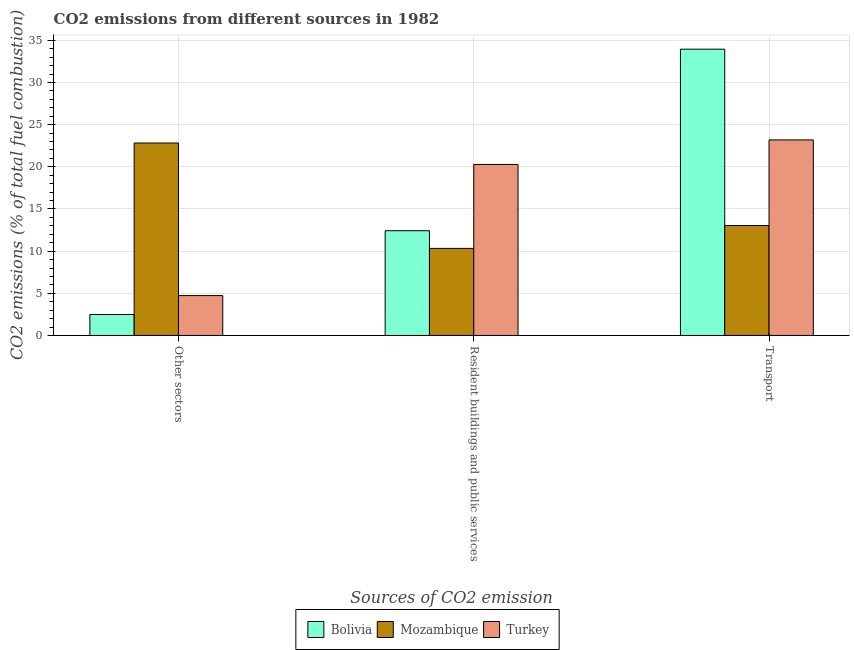How many bars are there on the 3rd tick from the right?
Keep it short and to the point. 3. What is the label of the 2nd group of bars from the left?
Provide a succinct answer. Resident buildings and public services. What is the percentage of co2 emissions from resident buildings and public services in Turkey?
Make the answer very short. 20.28. Across all countries, what is the maximum percentage of co2 emissions from resident buildings and public services?
Ensure brevity in your answer.  20.28. Across all countries, what is the minimum percentage of co2 emissions from transport?
Make the answer very short. 13.04. In which country was the percentage of co2 emissions from other sectors maximum?
Your answer should be very brief. Mozambique. In which country was the percentage of co2 emissions from resident buildings and public services minimum?
Your response must be concise. Mozambique. What is the total percentage of co2 emissions from other sectors in the graph?
Ensure brevity in your answer.  30.04. What is the difference between the percentage of co2 emissions from other sectors in Mozambique and that in Bolivia?
Offer a terse response. 20.34. What is the difference between the percentage of co2 emissions from other sectors in Bolivia and the percentage of co2 emissions from resident buildings and public services in Mozambique?
Your answer should be very brief. -7.84. What is the average percentage of co2 emissions from other sectors per country?
Offer a very short reply. 10.01. What is the difference between the percentage of co2 emissions from transport and percentage of co2 emissions from resident buildings and public services in Bolivia?
Provide a short and direct response. 21.53. In how many countries, is the percentage of co2 emissions from other sectors greater than 21 %?
Offer a terse response. 1. What is the ratio of the percentage of co2 emissions from resident buildings and public services in Turkey to that in Mozambique?
Your answer should be very brief. 1.96. Is the percentage of co2 emissions from other sectors in Turkey less than that in Bolivia?
Your answer should be compact. No. Is the difference between the percentage of co2 emissions from resident buildings and public services in Bolivia and Turkey greater than the difference between the percentage of co2 emissions from other sectors in Bolivia and Turkey?
Your answer should be compact. No. What is the difference between the highest and the second highest percentage of co2 emissions from other sectors?
Ensure brevity in your answer.  18.1. What is the difference between the highest and the lowest percentage of co2 emissions from other sectors?
Offer a very short reply. 20.34. In how many countries, is the percentage of co2 emissions from resident buildings and public services greater than the average percentage of co2 emissions from resident buildings and public services taken over all countries?
Your answer should be compact. 1. Is the sum of the percentage of co2 emissions from transport in Turkey and Mozambique greater than the maximum percentage of co2 emissions from other sectors across all countries?
Provide a succinct answer. Yes. What does the 2nd bar from the left in Transport represents?
Your response must be concise. Mozambique. Are all the bars in the graph horizontal?
Your response must be concise. No. Does the graph contain grids?
Ensure brevity in your answer.  Yes. Where does the legend appear in the graph?
Ensure brevity in your answer.  Bottom center. How many legend labels are there?
Offer a terse response. 3. What is the title of the graph?
Offer a very short reply. CO2 emissions from different sources in 1982. Does "Caribbean small states" appear as one of the legend labels in the graph?
Your response must be concise. No. What is the label or title of the X-axis?
Your answer should be very brief. Sources of CO2 emission. What is the label or title of the Y-axis?
Your response must be concise. CO2 emissions (% of total fuel combustion). What is the CO2 emissions (% of total fuel combustion) in Bolivia in Other sectors?
Give a very brief answer. 2.48. What is the CO2 emissions (% of total fuel combustion) in Mozambique in Other sectors?
Your answer should be very brief. 22.83. What is the CO2 emissions (% of total fuel combustion) in Turkey in Other sectors?
Make the answer very short. 4.73. What is the CO2 emissions (% of total fuel combustion) in Bolivia in Resident buildings and public services?
Offer a very short reply. 12.42. What is the CO2 emissions (% of total fuel combustion) in Mozambique in Resident buildings and public services?
Give a very brief answer. 10.33. What is the CO2 emissions (% of total fuel combustion) in Turkey in Resident buildings and public services?
Offer a very short reply. 20.28. What is the CO2 emissions (% of total fuel combustion) in Bolivia in Transport?
Your answer should be compact. 33.95. What is the CO2 emissions (% of total fuel combustion) in Mozambique in Transport?
Give a very brief answer. 13.04. What is the CO2 emissions (% of total fuel combustion) in Turkey in Transport?
Your answer should be compact. 23.19. Across all Sources of CO2 emission, what is the maximum CO2 emissions (% of total fuel combustion) in Bolivia?
Make the answer very short. 33.95. Across all Sources of CO2 emission, what is the maximum CO2 emissions (% of total fuel combustion) in Mozambique?
Give a very brief answer. 22.83. Across all Sources of CO2 emission, what is the maximum CO2 emissions (% of total fuel combustion) in Turkey?
Your response must be concise. 23.19. Across all Sources of CO2 emission, what is the minimum CO2 emissions (% of total fuel combustion) of Bolivia?
Provide a short and direct response. 2.48. Across all Sources of CO2 emission, what is the minimum CO2 emissions (% of total fuel combustion) of Mozambique?
Your answer should be very brief. 10.33. Across all Sources of CO2 emission, what is the minimum CO2 emissions (% of total fuel combustion) of Turkey?
Provide a short and direct response. 4.73. What is the total CO2 emissions (% of total fuel combustion) of Bolivia in the graph?
Give a very brief answer. 48.86. What is the total CO2 emissions (% of total fuel combustion) in Mozambique in the graph?
Provide a short and direct response. 46.2. What is the total CO2 emissions (% of total fuel combustion) in Turkey in the graph?
Provide a short and direct response. 48.21. What is the difference between the CO2 emissions (% of total fuel combustion) of Bolivia in Other sectors and that in Resident buildings and public services?
Offer a terse response. -9.94. What is the difference between the CO2 emissions (% of total fuel combustion) in Turkey in Other sectors and that in Resident buildings and public services?
Your answer should be compact. -15.55. What is the difference between the CO2 emissions (% of total fuel combustion) of Bolivia in Other sectors and that in Transport?
Ensure brevity in your answer.  -31.47. What is the difference between the CO2 emissions (% of total fuel combustion) of Mozambique in Other sectors and that in Transport?
Your response must be concise. 9.78. What is the difference between the CO2 emissions (% of total fuel combustion) of Turkey in Other sectors and that in Transport?
Your response must be concise. -18.46. What is the difference between the CO2 emissions (% of total fuel combustion) in Bolivia in Resident buildings and public services and that in Transport?
Ensure brevity in your answer.  -21.53. What is the difference between the CO2 emissions (% of total fuel combustion) in Mozambique in Resident buildings and public services and that in Transport?
Give a very brief answer. -2.72. What is the difference between the CO2 emissions (% of total fuel combustion) in Turkey in Resident buildings and public services and that in Transport?
Your answer should be compact. -2.91. What is the difference between the CO2 emissions (% of total fuel combustion) in Bolivia in Other sectors and the CO2 emissions (% of total fuel combustion) in Mozambique in Resident buildings and public services?
Your response must be concise. -7.84. What is the difference between the CO2 emissions (% of total fuel combustion) in Bolivia in Other sectors and the CO2 emissions (% of total fuel combustion) in Turkey in Resident buildings and public services?
Your answer should be very brief. -17.8. What is the difference between the CO2 emissions (% of total fuel combustion) in Mozambique in Other sectors and the CO2 emissions (% of total fuel combustion) in Turkey in Resident buildings and public services?
Your response must be concise. 2.54. What is the difference between the CO2 emissions (% of total fuel combustion) in Bolivia in Other sectors and the CO2 emissions (% of total fuel combustion) in Mozambique in Transport?
Provide a short and direct response. -10.56. What is the difference between the CO2 emissions (% of total fuel combustion) in Bolivia in Other sectors and the CO2 emissions (% of total fuel combustion) in Turkey in Transport?
Give a very brief answer. -20.71. What is the difference between the CO2 emissions (% of total fuel combustion) of Mozambique in Other sectors and the CO2 emissions (% of total fuel combustion) of Turkey in Transport?
Your answer should be very brief. -0.37. What is the difference between the CO2 emissions (% of total fuel combustion) in Bolivia in Resident buildings and public services and the CO2 emissions (% of total fuel combustion) in Mozambique in Transport?
Ensure brevity in your answer.  -0.62. What is the difference between the CO2 emissions (% of total fuel combustion) in Bolivia in Resident buildings and public services and the CO2 emissions (% of total fuel combustion) in Turkey in Transport?
Your answer should be very brief. -10.77. What is the difference between the CO2 emissions (% of total fuel combustion) in Mozambique in Resident buildings and public services and the CO2 emissions (% of total fuel combustion) in Turkey in Transport?
Provide a succinct answer. -12.87. What is the average CO2 emissions (% of total fuel combustion) in Bolivia per Sources of CO2 emission?
Make the answer very short. 16.29. What is the average CO2 emissions (% of total fuel combustion) in Mozambique per Sources of CO2 emission?
Offer a very short reply. 15.4. What is the average CO2 emissions (% of total fuel combustion) in Turkey per Sources of CO2 emission?
Give a very brief answer. 16.07. What is the difference between the CO2 emissions (% of total fuel combustion) of Bolivia and CO2 emissions (% of total fuel combustion) of Mozambique in Other sectors?
Provide a short and direct response. -20.34. What is the difference between the CO2 emissions (% of total fuel combustion) of Bolivia and CO2 emissions (% of total fuel combustion) of Turkey in Other sectors?
Give a very brief answer. -2.25. What is the difference between the CO2 emissions (% of total fuel combustion) of Mozambique and CO2 emissions (% of total fuel combustion) of Turkey in Other sectors?
Your response must be concise. 18.1. What is the difference between the CO2 emissions (% of total fuel combustion) in Bolivia and CO2 emissions (% of total fuel combustion) in Mozambique in Resident buildings and public services?
Your answer should be very brief. 2.1. What is the difference between the CO2 emissions (% of total fuel combustion) of Bolivia and CO2 emissions (% of total fuel combustion) of Turkey in Resident buildings and public services?
Give a very brief answer. -7.86. What is the difference between the CO2 emissions (% of total fuel combustion) in Mozambique and CO2 emissions (% of total fuel combustion) in Turkey in Resident buildings and public services?
Offer a very short reply. -9.96. What is the difference between the CO2 emissions (% of total fuel combustion) in Bolivia and CO2 emissions (% of total fuel combustion) in Mozambique in Transport?
Your answer should be very brief. 20.91. What is the difference between the CO2 emissions (% of total fuel combustion) of Bolivia and CO2 emissions (% of total fuel combustion) of Turkey in Transport?
Your answer should be compact. 10.76. What is the difference between the CO2 emissions (% of total fuel combustion) of Mozambique and CO2 emissions (% of total fuel combustion) of Turkey in Transport?
Ensure brevity in your answer.  -10.15. What is the ratio of the CO2 emissions (% of total fuel combustion) in Mozambique in Other sectors to that in Resident buildings and public services?
Offer a very short reply. 2.21. What is the ratio of the CO2 emissions (% of total fuel combustion) of Turkey in Other sectors to that in Resident buildings and public services?
Make the answer very short. 0.23. What is the ratio of the CO2 emissions (% of total fuel combustion) in Bolivia in Other sectors to that in Transport?
Your answer should be compact. 0.07. What is the ratio of the CO2 emissions (% of total fuel combustion) of Turkey in Other sectors to that in Transport?
Your answer should be compact. 0.2. What is the ratio of the CO2 emissions (% of total fuel combustion) in Bolivia in Resident buildings and public services to that in Transport?
Make the answer very short. 0.37. What is the ratio of the CO2 emissions (% of total fuel combustion) of Mozambique in Resident buildings and public services to that in Transport?
Make the answer very short. 0.79. What is the ratio of the CO2 emissions (% of total fuel combustion) in Turkey in Resident buildings and public services to that in Transport?
Give a very brief answer. 0.87. What is the difference between the highest and the second highest CO2 emissions (% of total fuel combustion) in Bolivia?
Keep it short and to the point. 21.53. What is the difference between the highest and the second highest CO2 emissions (% of total fuel combustion) in Mozambique?
Give a very brief answer. 9.78. What is the difference between the highest and the second highest CO2 emissions (% of total fuel combustion) of Turkey?
Ensure brevity in your answer.  2.91. What is the difference between the highest and the lowest CO2 emissions (% of total fuel combustion) of Bolivia?
Ensure brevity in your answer.  31.47. What is the difference between the highest and the lowest CO2 emissions (% of total fuel combustion) of Turkey?
Make the answer very short. 18.46. 